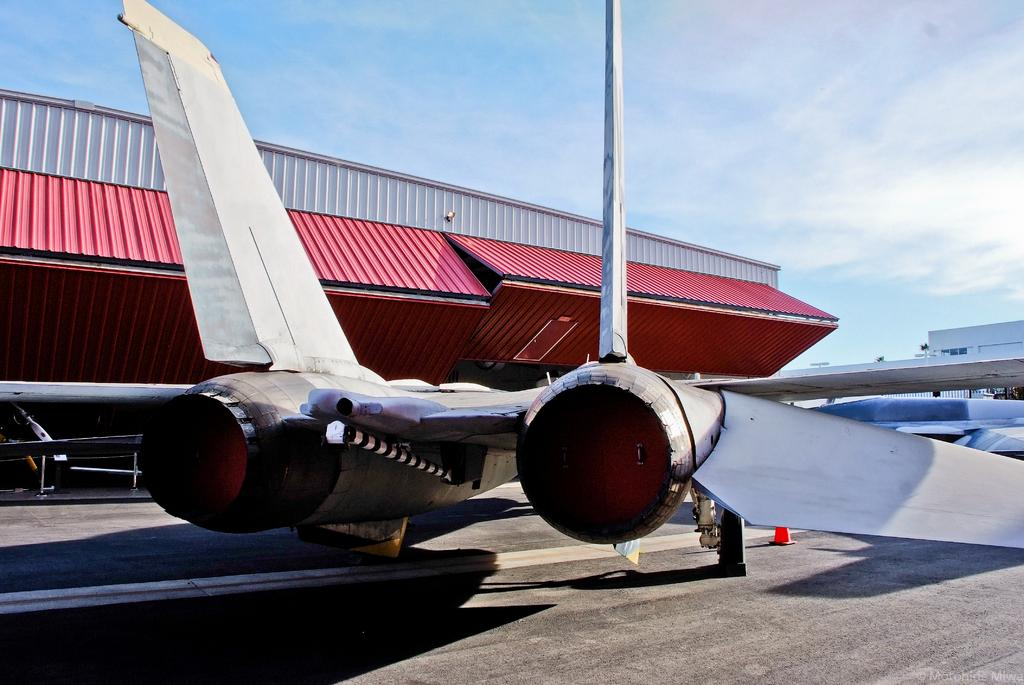What is the main subject of the image? The main subject of the image is planes. Where are the planes located in the image? The planes are in the front of the image. What is visible at the bottom of the image? There is a road at the bottom of the image. What structure can be seen to the left of the image? There is a shed to the left of the image. What is visible in the sky at the top of the image? There are clouds in the sky at the top of the image. What type of pickle is being used as a propeller for the planes in the image? There is no pickle present in the image, and the planes do not have any unusual propellers. Can you tell me how many astronauts are visible in the image? There is no mention of astronauts or space in the image; it features planes, a road, a shed, and clouds. 